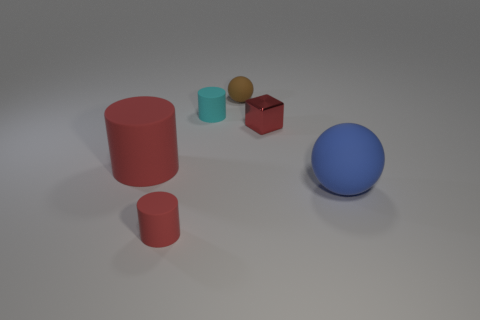How many red cylinders must be subtracted to get 1 red cylinders? 1 Add 1 small cylinders. How many objects exist? 7 Subtract all balls. How many objects are left? 4 Subtract all cyan cylinders. Subtract all tiny red shiny objects. How many objects are left? 4 Add 3 tiny brown balls. How many tiny brown balls are left? 4 Add 1 large brown matte balls. How many large brown matte balls exist? 1 Subtract 1 cyan cylinders. How many objects are left? 5 